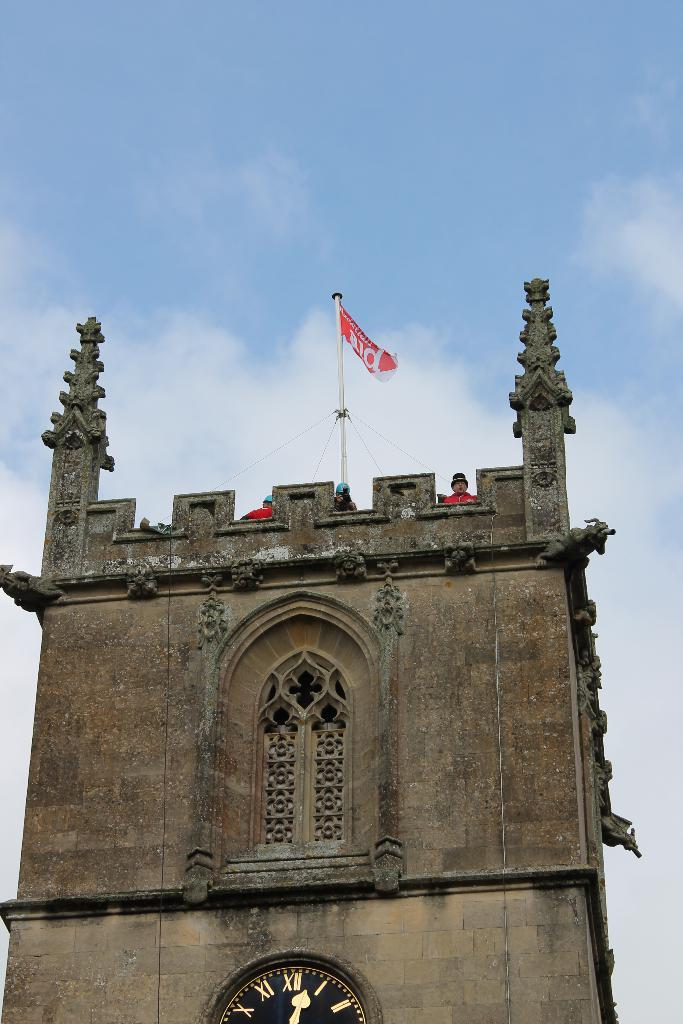What is the main structure in the image? There is a building in the image. How many people are present in the image? There are three persons in the image. What can be seen flying in the image? There is a flag in the image. What is visible in the background of the image? The sky is visible in the background of the image. What colors can be seen in the sky? The sky has white and blue colors. What invention is being demonstrated by the persons in the image? There is no invention being demonstrated in the image; it only shows a building, three persons, a flag, and the sky. 